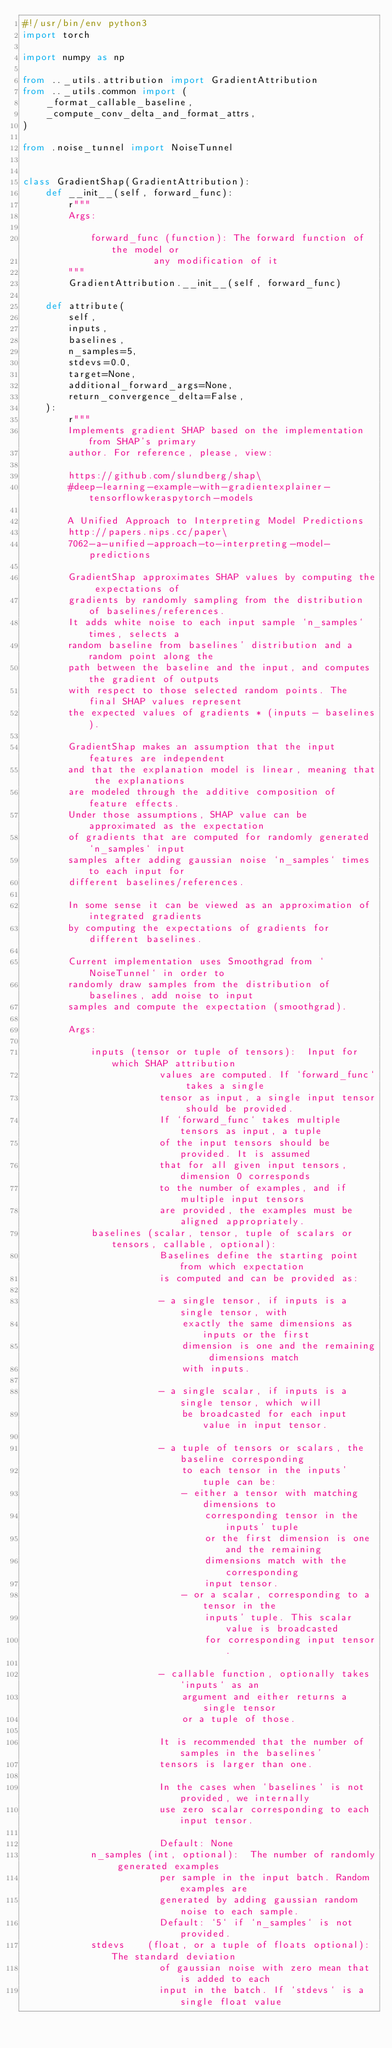Convert code to text. <code><loc_0><loc_0><loc_500><loc_500><_Python_>#!/usr/bin/env python3
import torch

import numpy as np

from .._utils.attribution import GradientAttribution
from .._utils.common import (
    _format_callable_baseline,
    _compute_conv_delta_and_format_attrs,
)

from .noise_tunnel import NoiseTunnel


class GradientShap(GradientAttribution):
    def __init__(self, forward_func):
        r"""
        Args:

            forward_func (function): The forward function of the model or
                       any modification of it
        """
        GradientAttribution.__init__(self, forward_func)

    def attribute(
        self,
        inputs,
        baselines,
        n_samples=5,
        stdevs=0.0,
        target=None,
        additional_forward_args=None,
        return_convergence_delta=False,
    ):
        r"""
        Implements gradient SHAP based on the implementation from SHAP's primary
        author. For reference, please, view:

        https://github.com/slundberg/shap\
        #deep-learning-example-with-gradientexplainer-tensorflowkeraspytorch-models

        A Unified Approach to Interpreting Model Predictions
        http://papers.nips.cc/paper\
        7062-a-unified-approach-to-interpreting-model-predictions

        GradientShap approximates SHAP values by computing the expectations of
        gradients by randomly sampling from the distribution of baselines/references.
        It adds white noise to each input sample `n_samples` times, selects a
        random baseline from baselines' distribution and a random point along the
        path between the baseline and the input, and computes the gradient of outputs
        with respect to those selected random points. The final SHAP values represent
        the expected values of gradients * (inputs - baselines).

        GradientShap makes an assumption that the input features are independent
        and that the explanation model is linear, meaning that the explanations
        are modeled through the additive composition of feature effects.
        Under those assumptions, SHAP value can be approximated as the expectation
        of gradients that are computed for randomly generated `n_samples` input
        samples after adding gaussian noise `n_samples` times to each input for
        different baselines/references.

        In some sense it can be viewed as an approximation of integrated gradients
        by computing the expectations of gradients for different baselines.

        Current implementation uses Smoothgrad from `NoiseTunnel` in order to
        randomly draw samples from the distribution of baselines, add noise to input
        samples and compute the expectation (smoothgrad).

        Args:

            inputs (tensor or tuple of tensors):  Input for which SHAP attribution
                        values are computed. If `forward_func` takes a single
                        tensor as input, a single input tensor should be provided.
                        If `forward_func` takes multiple tensors as input, a tuple
                        of the input tensors should be provided. It is assumed
                        that for all given input tensors, dimension 0 corresponds
                        to the number of examples, and if multiple input tensors
                        are provided, the examples must be aligned appropriately.
            baselines (scalar, tensor, tuple of scalars or tensors, callable, optional):
                        Baselines define the starting point from which expectation
                        is computed and can be provided as:

                        - a single tensor, if inputs is a single tensor, with
                            exactly the same dimensions as inputs or the first
                            dimension is one and the remaining dimensions match
                            with inputs.

                        - a single scalar, if inputs is a single tensor, which will
                            be broadcasted for each input value in input tensor.

                        - a tuple of tensors or scalars, the baseline corresponding
                            to each tensor in the inputs' tuple can be:
                            - either a tensor with matching dimensions to
                                corresponding tensor in the inputs' tuple
                                or the first dimension is one and the remaining
                                dimensions match with the corresponding
                                input tensor.
                            - or a scalar, corresponding to a tensor in the
                                inputs' tuple. This scalar value is broadcasted
                                for corresponding input tensor.

                        - callable function, optionally takes `inputs` as an
                            argument and either returns a single tensor
                            or a tuple of those.

                        It is recommended that the number of samples in the baselines'
                        tensors is larger than one.

                        In the cases when `baselines` is not provided, we internally
                        use zero scalar corresponding to each input tensor.

                        Default: None
            n_samples (int, optional):  The number of randomly generated examples
                        per sample in the input batch. Random examples are
                        generated by adding gaussian random noise to each sample.
                        Default: `5` if `n_samples` is not provided.
            stdevs    (float, or a tuple of floats optional): The standard deviation
                        of gaussian noise with zero mean that is added to each
                        input in the batch. If `stdevs` is a single float value</code> 